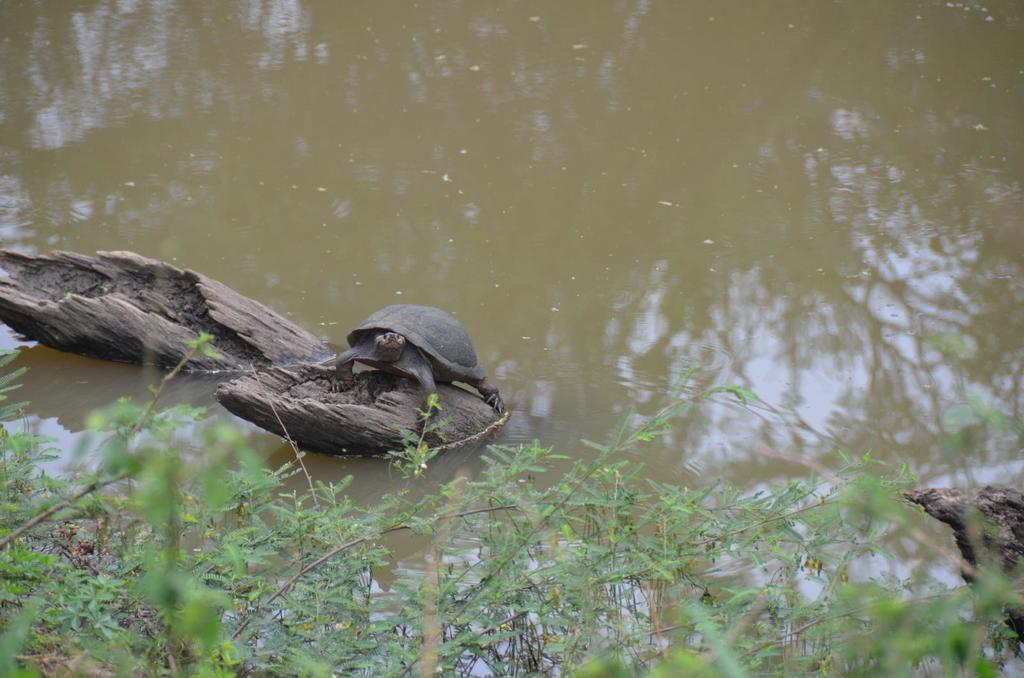What animal is on a tree in the image? There is a tortoise on a tree in the image. What type of vegetation is present in the image? There are trees in the image. What natural element is visible in the image? Water is visible in the image. What is the limit of the cent in the image? There is no mention of a cent or any limit in the image; it features a tortoise on a tree and trees with water visible. 